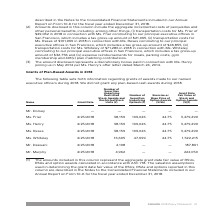According to Square's financial document, What does the table show? Information regarding grants of awards made to our named executive officers during 2018. The document states: "The following table sets forth information regarding grants of awards made to our named executive officers during 2018. We did not grant any plan-base..." Also, What does the column “Grant Date Fair Value of Stock and Option Awards” represent? The aggregate grant date fair value of RSUs, RSAs and option awards calculated in accordance with ASC 718.. The document states: "(1) The amounts included in this column represent the aggregate grant date fair value of RSUs, RSAs and option awards calculated in accordance with AS..." Also, When is the Grant Date for all the executive officers? According to the financial document, 4/25/2018. The relevant text states: "Ms. Friar 4/25/2018 38,159 109,026 44.75 3,479,299..." Also, can you calculate: What is the difference between the smallest and largest amount of Grant Date Fair Value of Stock and Option Awards? Based on the calculation: 3,479,299 - 187,861, the result is 3291438. This is based on the information: "Ms. Friar 4/25/2018 38,159 109,026 44.75 3,479,299 Mr. Daswani 4/25/2018 4,198 — — 187,861..." The key data points involved are: 187,861, 3,479,299. Also, can you calculate: What is the average Number of Securities Underlying Restricted Stock Awards and Restricted Stock Units for those who received it? To answer this question, I need to perform calculations using the financial data. The calculation is: (38,159 + 38,159 + 38,159 + 16,695 + 4,198 + 4,962) / 6 , which equals 23388.67. This is based on the information: "Ms. Whiteley 4/25/2018 16,695 47,699 44.75 1,522,215 Ms. Friar 4/25/2018 38,159 109,026 44.75 3,479,299 Mr. Daswani 4/25/2018 4,198 — — 187,861 Mr. Murphy 4/25/2018 4,962 — — 222,050..." The key data points involved are: 16,695, 38,159, 4,198. Also, can you calculate: What is the ratio of Ms. Henry’s to Ms. Whiteley’s Number of Securities Underlying Options? Based on the calculation: 109,026 / 47,699 , the result is 2.29. This is based on the information: "Ms. Friar 4/25/2018 38,159 109,026 44.75 3,479,299 Ms. Whiteley 4/25/2018 16,695 47,699 44.75 1,522,215..." The key data points involved are: 109,026, 47,699. 